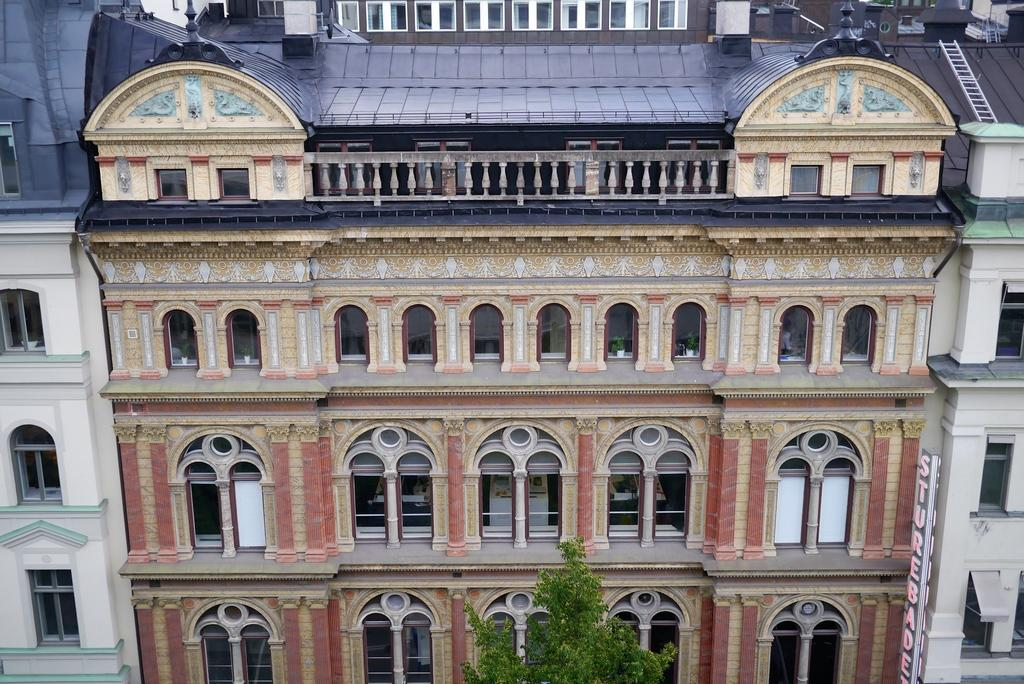What is the main subject in the center of the image? There is a building in the center of the image. What type of vegetation can be seen at the bottom of the image? There is a tree at the bottom of the image. What type of sign is hanging from the cannon in the image? There is no sign or cannon present in the image. What type of business is being conducted in the building in the image? The image does not provide information about the type of business being conducted in the building. 